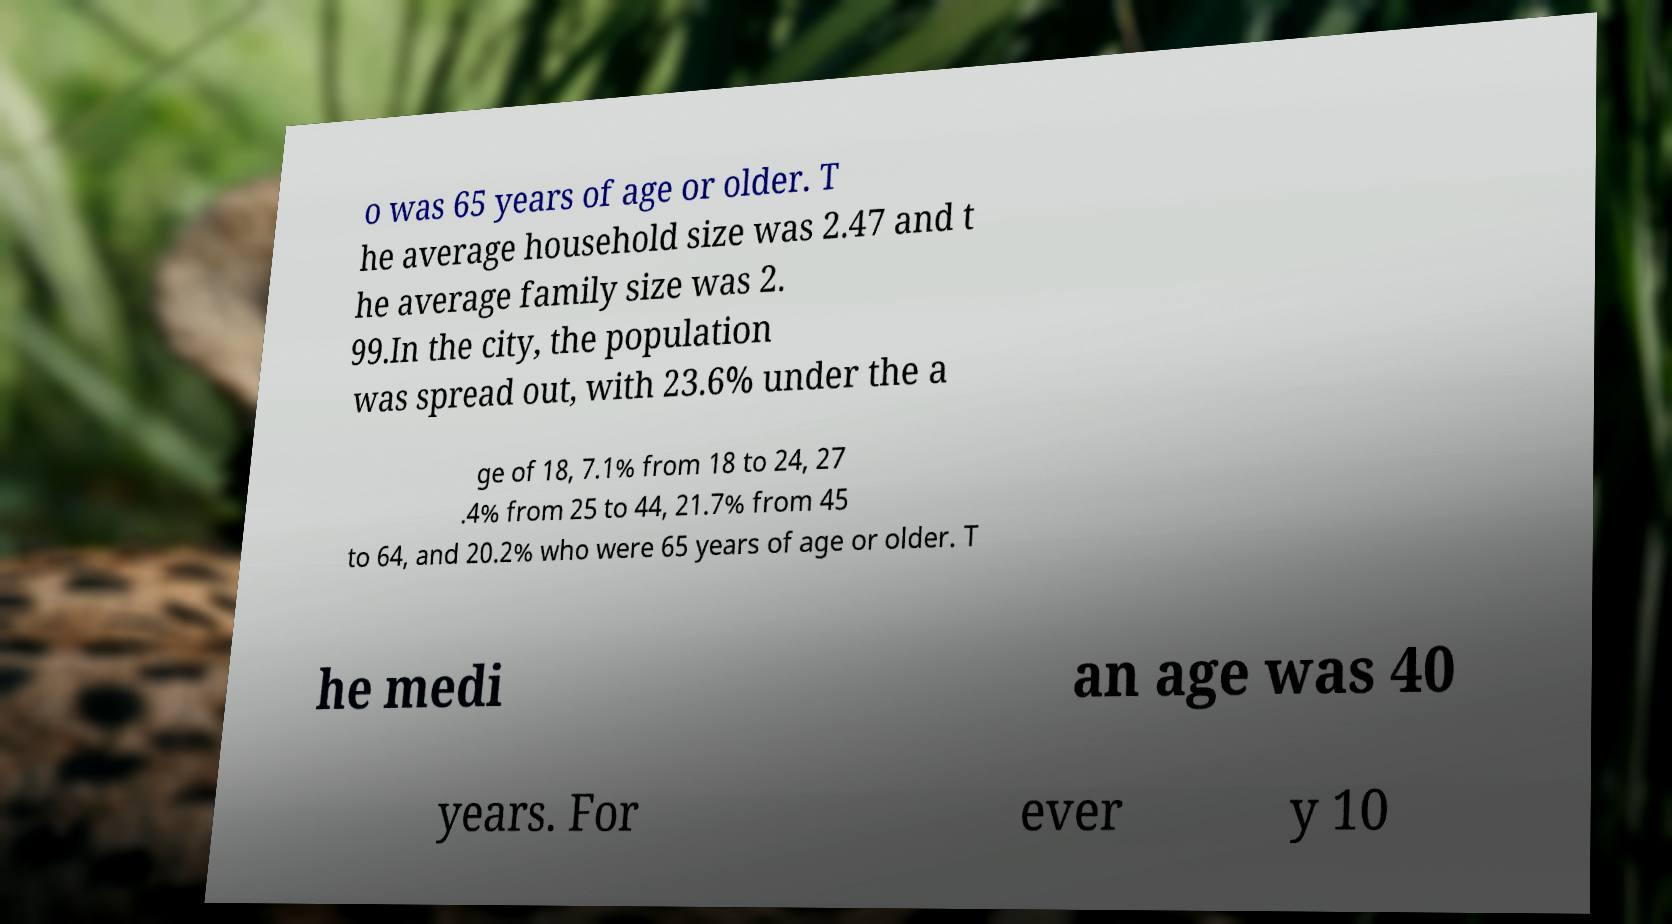Could you extract and type out the text from this image? o was 65 years of age or older. T he average household size was 2.47 and t he average family size was 2. 99.In the city, the population was spread out, with 23.6% under the a ge of 18, 7.1% from 18 to 24, 27 .4% from 25 to 44, 21.7% from 45 to 64, and 20.2% who were 65 years of age or older. T he medi an age was 40 years. For ever y 10 